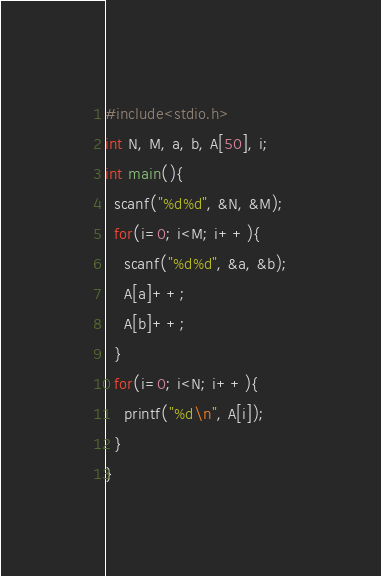Convert code to text. <code><loc_0><loc_0><loc_500><loc_500><_C_>#include<stdio.h>
int N, M, a, b, A[50], i;
int main(){
  scanf("%d%d", &N, &M);
  for(i=0; i<M; i++){
    scanf("%d%d", &a, &b);
    A[a]++;
    A[b]++;
  }
  for(i=0; i<N; i++){
    printf("%d\n", A[i]);
  }
}
</code> 